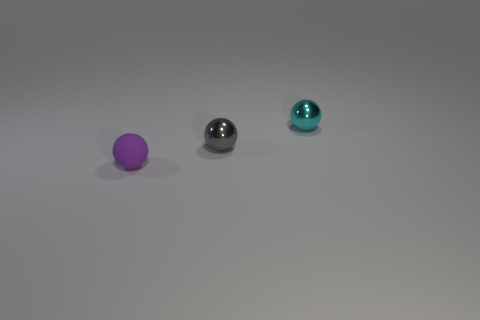Add 1 tiny matte things. How many objects exist? 4 Add 1 gray shiny things. How many gray shiny things are left? 2 Add 3 tiny brown cylinders. How many tiny brown cylinders exist? 3 Subtract 0 cyan cubes. How many objects are left? 3 Subtract all yellow objects. Subtract all metal objects. How many objects are left? 1 